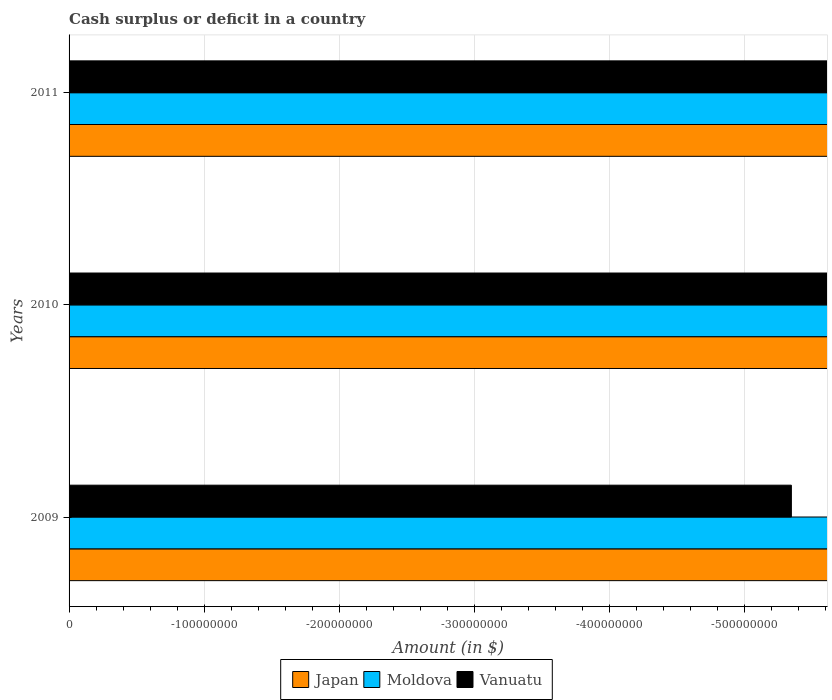How many different coloured bars are there?
Ensure brevity in your answer.  0. Are the number of bars per tick equal to the number of legend labels?
Make the answer very short. No. How many bars are there on the 1st tick from the top?
Give a very brief answer. 0. What is the label of the 3rd group of bars from the top?
Ensure brevity in your answer.  2009. What is the amount of cash surplus or deficit in Vanuatu in 2009?
Provide a succinct answer. 0. Across all years, what is the minimum amount of cash surplus or deficit in Japan?
Offer a very short reply. 0. What is the average amount of cash surplus or deficit in Vanuatu per year?
Your answer should be compact. 0. In how many years, is the amount of cash surplus or deficit in Moldova greater than -20000000 $?
Ensure brevity in your answer.  0. In how many years, is the amount of cash surplus or deficit in Japan greater than the average amount of cash surplus or deficit in Japan taken over all years?
Offer a very short reply. 0. Is it the case that in every year, the sum of the amount of cash surplus or deficit in Vanuatu and amount of cash surplus or deficit in Moldova is greater than the amount of cash surplus or deficit in Japan?
Your answer should be compact. No. How many bars are there?
Keep it short and to the point. 0. Are the values on the major ticks of X-axis written in scientific E-notation?
Give a very brief answer. No. Does the graph contain any zero values?
Offer a very short reply. Yes. Does the graph contain grids?
Offer a very short reply. Yes. Where does the legend appear in the graph?
Your answer should be very brief. Bottom center. What is the title of the graph?
Provide a short and direct response. Cash surplus or deficit in a country. Does "Cyprus" appear as one of the legend labels in the graph?
Keep it short and to the point. No. What is the label or title of the X-axis?
Ensure brevity in your answer.  Amount (in $). What is the Amount (in $) in Japan in 2009?
Provide a succinct answer. 0. What is the Amount (in $) in Japan in 2011?
Your answer should be compact. 0. What is the total Amount (in $) of Moldova in the graph?
Keep it short and to the point. 0. What is the total Amount (in $) of Vanuatu in the graph?
Give a very brief answer. 0. What is the average Amount (in $) in Japan per year?
Offer a very short reply. 0. What is the average Amount (in $) in Vanuatu per year?
Give a very brief answer. 0. 